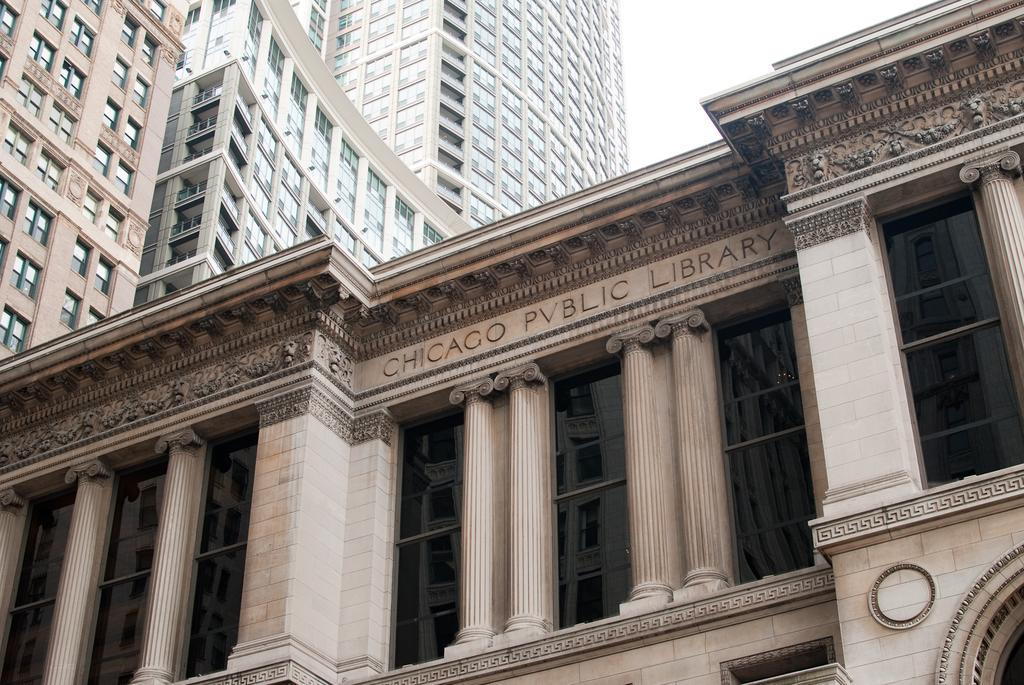What type of structures can be seen in the image? There are buildings in the image. Can you describe any specific details about the buildings? One of the buildings has text on it. What part of the natural environment is visible in the image? The sky is visible in the top right corner of the image. What type of lunch is being served in the image? There is no lunch present in the image; it features buildings and text on one of them. What scientific discovery is depicted in the image? There is no scientific discovery depicted in the image; it focuses on buildings and text. 